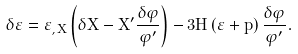<formula> <loc_0><loc_0><loc_500><loc_500>\delta \varepsilon = \varepsilon _ { , X } \left ( \delta X - X ^ { \prime } \frac { \delta \varphi } { \varphi ^ { \prime } } \right ) - 3 H \left ( \varepsilon + p \right ) \frac { \delta \varphi } { \varphi ^ { \prime } } .</formula> 